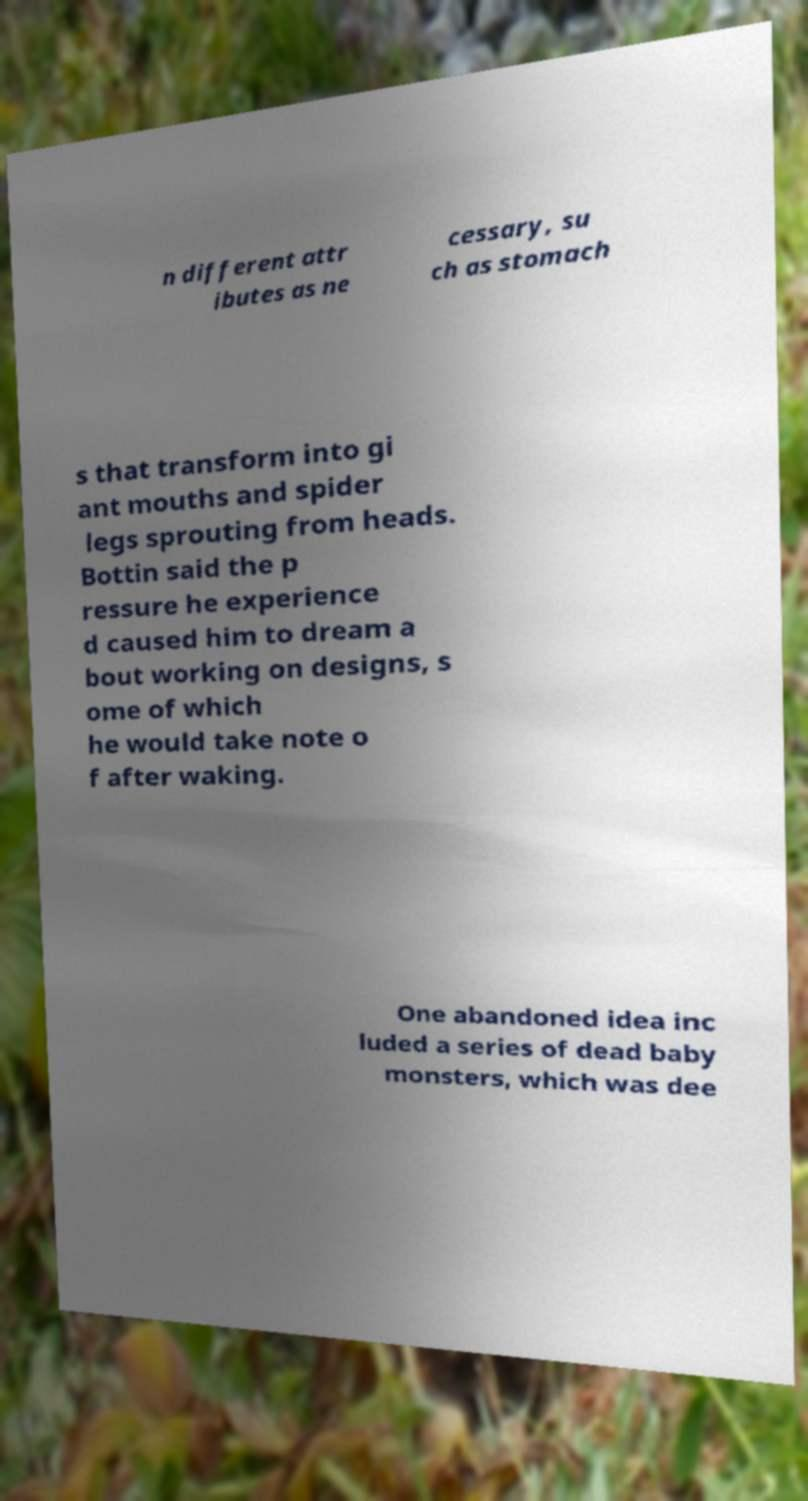Could you assist in decoding the text presented in this image and type it out clearly? n different attr ibutes as ne cessary, su ch as stomach s that transform into gi ant mouths and spider legs sprouting from heads. Bottin said the p ressure he experience d caused him to dream a bout working on designs, s ome of which he would take note o f after waking. One abandoned idea inc luded a series of dead baby monsters, which was dee 